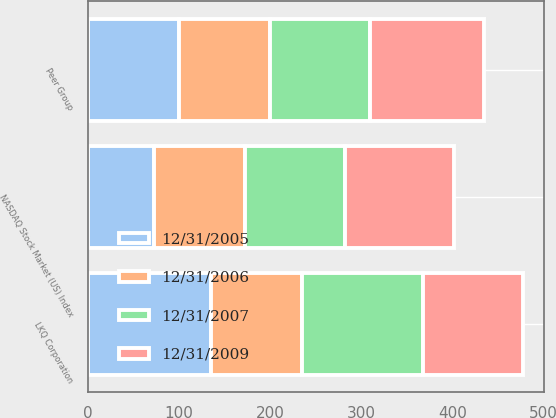Convert chart. <chart><loc_0><loc_0><loc_500><loc_500><stacked_bar_chart><ecel><fcel>LKQ Corporation<fcel>NASDAQ Stock Market (US) Index<fcel>Peer Group<nl><fcel>12/31/2006<fcel>100<fcel>100<fcel>100<nl><fcel>12/31/2007<fcel>133<fcel>110<fcel>109<nl><fcel>12/31/2009<fcel>109<fcel>120<fcel>126<nl><fcel>12/31/2005<fcel>135<fcel>72<fcel>100<nl></chart> 